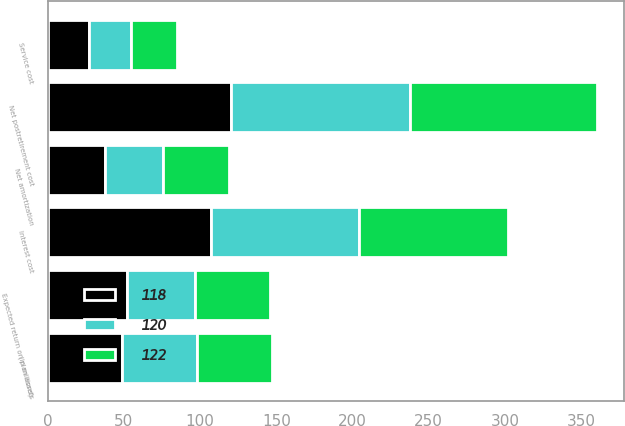<chart> <loc_0><loc_0><loc_500><loc_500><stacked_bar_chart><ecel><fcel>(in millions)<fcel>Service cost<fcel>Interest cost<fcel>Expected return on plan assets<fcel>Net amortization<fcel>Net postretirement cost<nl><fcel>118<fcel>49<fcel>27<fcel>107<fcel>52<fcel>38<fcel>120<nl><fcel>122<fcel>49<fcel>30<fcel>98<fcel>49<fcel>43<fcel>122<nl><fcel>120<fcel>49<fcel>28<fcel>97<fcel>45<fcel>38<fcel>118<nl></chart> 